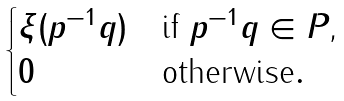Convert formula to latex. <formula><loc_0><loc_0><loc_500><loc_500>\begin{cases} \xi ( p ^ { - 1 } q ) & \text {if $p^{-1}q\in P$,} \\ 0 & \text {otherwise} . \end{cases}</formula> 